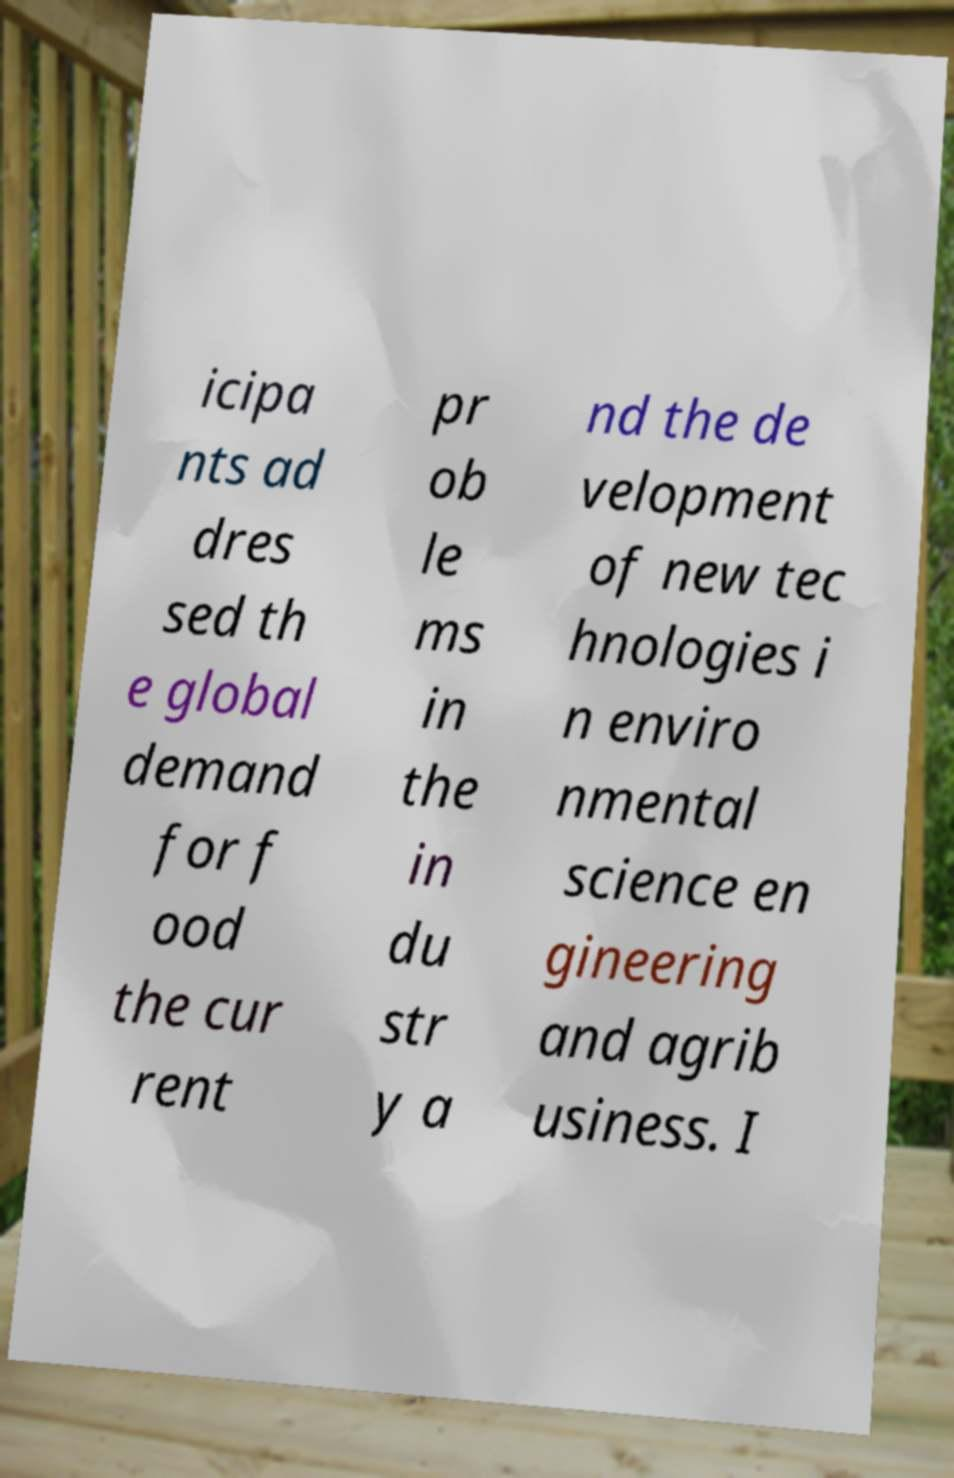Could you assist in decoding the text presented in this image and type it out clearly? icipa nts ad dres sed th e global demand for f ood the cur rent pr ob le ms in the in du str y a nd the de velopment of new tec hnologies i n enviro nmental science en gineering and agrib usiness. I 